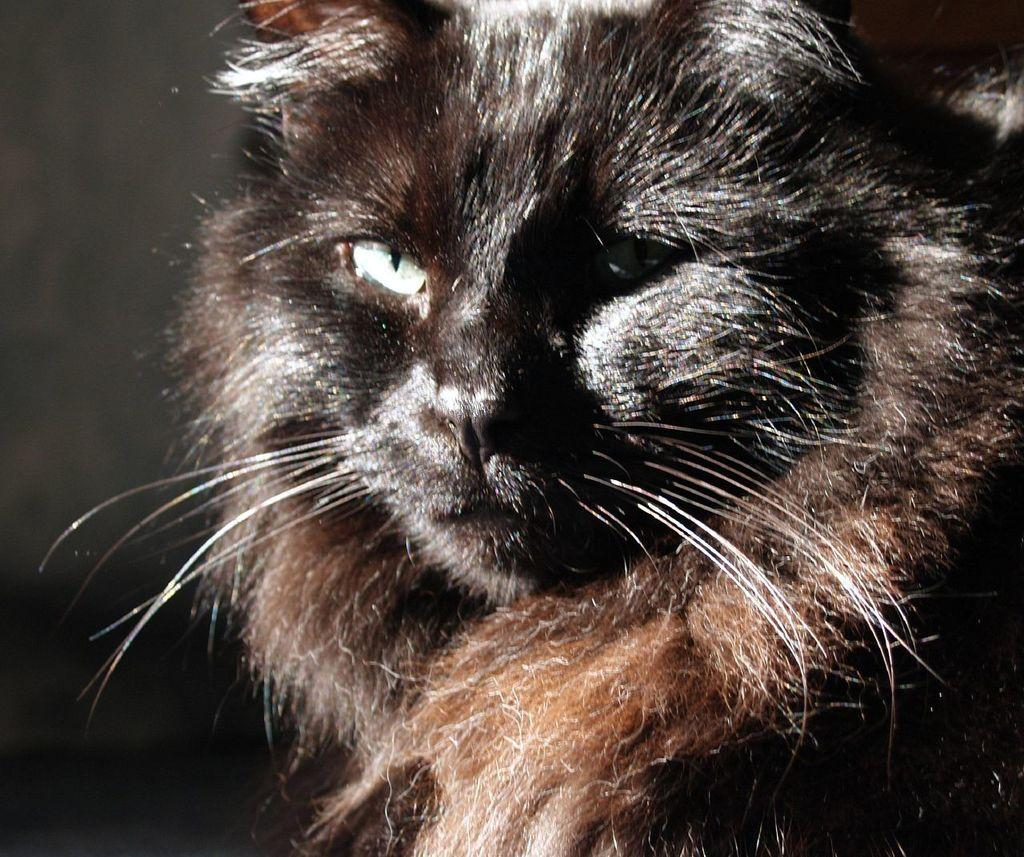What type of animal is in the image? There is a black color cat in the image. Can you describe the cat's appearance? The cat is black in color. What type of leather can be seen on the owl in the image? There is no owl or leather present in the image; it features a black color cat. 